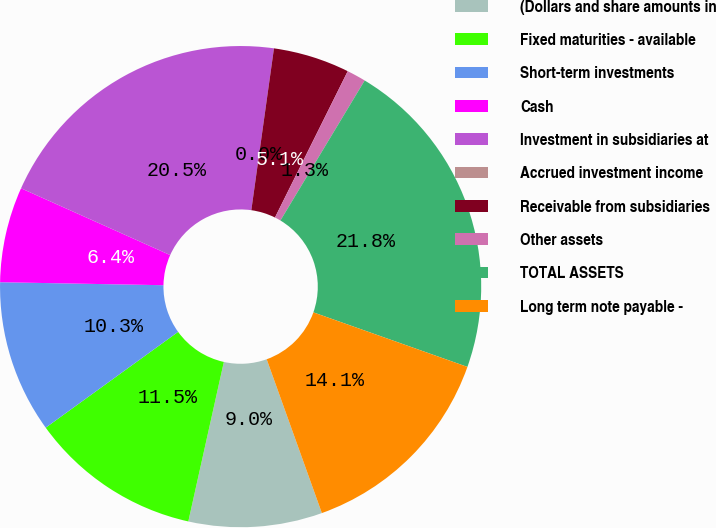Convert chart to OTSL. <chart><loc_0><loc_0><loc_500><loc_500><pie_chart><fcel>(Dollars and share amounts in<fcel>Fixed maturities - available<fcel>Short-term investments<fcel>Cash<fcel>Investment in subsidiaries at<fcel>Accrued investment income<fcel>Receivable from subsidiaries<fcel>Other assets<fcel>TOTAL ASSETS<fcel>Long term note payable -<nl><fcel>8.97%<fcel>11.54%<fcel>10.26%<fcel>6.41%<fcel>20.51%<fcel>0.0%<fcel>5.13%<fcel>1.28%<fcel>21.79%<fcel>14.1%<nl></chart> 